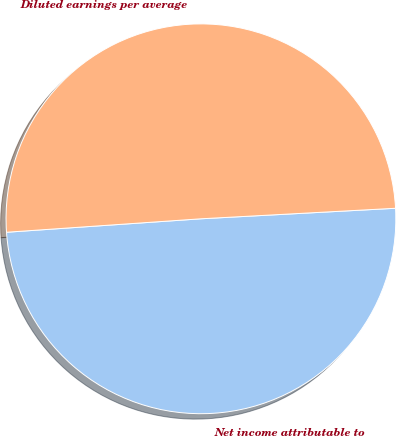<chart> <loc_0><loc_0><loc_500><loc_500><pie_chart><fcel>Net income attributable to<fcel>Diluted earnings per average<nl><fcel>49.76%<fcel>50.24%<nl></chart> 